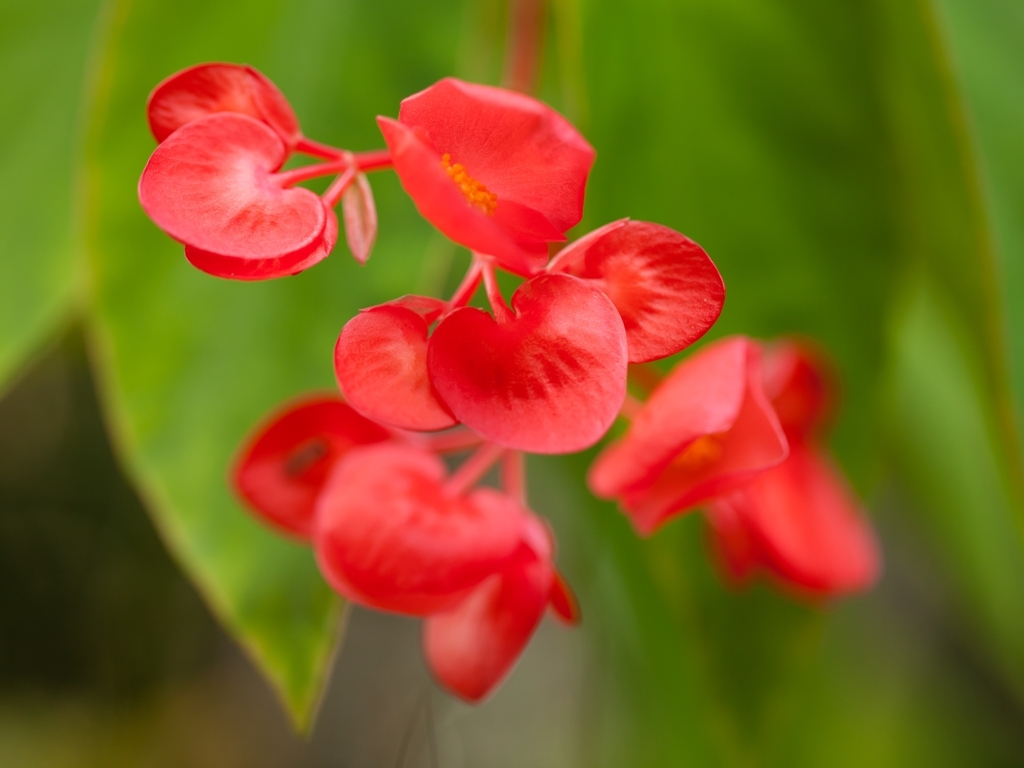What kind of lighting conditions appear to have contributed to the quality of this image? The quality of this image suggests the use of soft, natural lighting. There are no harsh shadows obscuring the details of the flower, and the colors are vivid but not oversaturated. This type of lighting often occurs in an outdoor setting during the morning or late afternoon hours, which are known for their gentle and flattering light. 